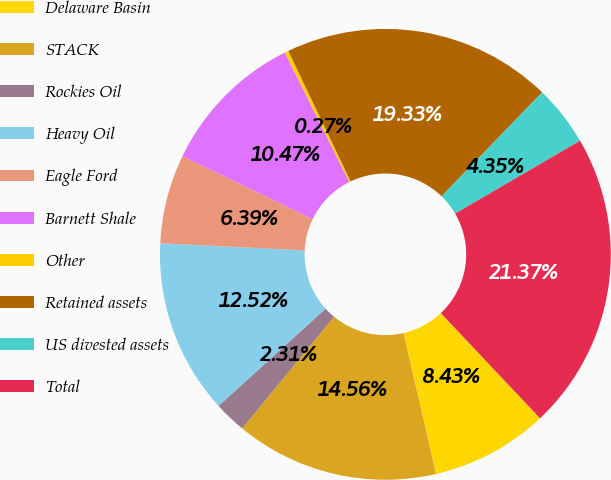Convert chart to OTSL. <chart><loc_0><loc_0><loc_500><loc_500><pie_chart><fcel>Delaware Basin<fcel>STACK<fcel>Rockies Oil<fcel>Heavy Oil<fcel>Eagle Ford<fcel>Barnett Shale<fcel>Other<fcel>Retained assets<fcel>US divested assets<fcel>Total<nl><fcel>8.43%<fcel>14.56%<fcel>2.31%<fcel>12.52%<fcel>6.39%<fcel>10.47%<fcel>0.27%<fcel>19.33%<fcel>4.35%<fcel>21.37%<nl></chart> 